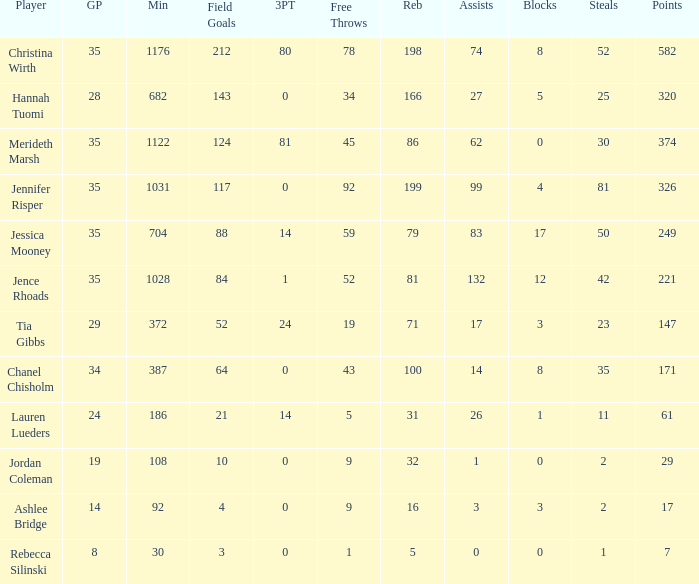What is the lowest number of games played by the player with 50 steals? 35.0. Write the full table. {'header': ['Player', 'GP', 'Min', 'Field Goals', '3PT', 'Free Throws', 'Reb', 'Assists', 'Blocks', 'Steals', 'Points'], 'rows': [['Christina Wirth', '35', '1176', '212', '80', '78', '198', '74', '8', '52', '582'], ['Hannah Tuomi', '28', '682', '143', '0', '34', '166', '27', '5', '25', '320'], ['Merideth Marsh', '35', '1122', '124', '81', '45', '86', '62', '0', '30', '374'], ['Jennifer Risper', '35', '1031', '117', '0', '92', '199', '99', '4', '81', '326'], ['Jessica Mooney', '35', '704', '88', '14', '59', '79', '83', '17', '50', '249'], ['Jence Rhoads', '35', '1028', '84', '1', '52', '81', '132', '12', '42', '221'], ['Tia Gibbs', '29', '372', '52', '24', '19', '71', '17', '3', '23', '147'], ['Chanel Chisholm', '34', '387', '64', '0', '43', '100', '14', '8', '35', '171'], ['Lauren Lueders', '24', '186', '21', '14', '5', '31', '26', '1', '11', '61'], ['Jordan Coleman', '19', '108', '10', '0', '9', '32', '1', '0', '2', '29'], ['Ashlee Bridge', '14', '92', '4', '0', '9', '16', '3', '3', '2', '17'], ['Rebecca Silinski', '8', '30', '3', '0', '1', '5', '0', '0', '1', '7']]} 